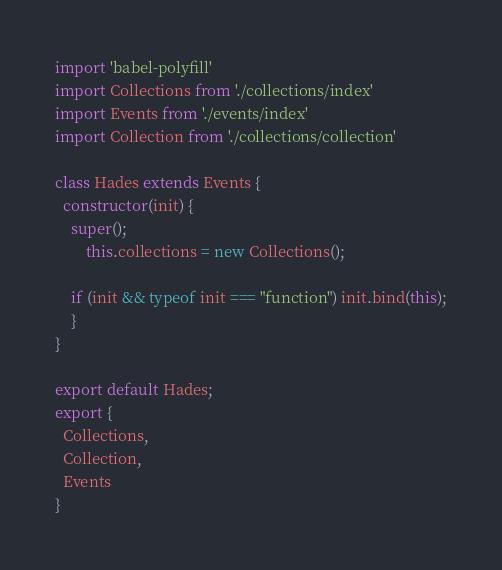Convert code to text. <code><loc_0><loc_0><loc_500><loc_500><_JavaScript_>import 'babel-polyfill'
import Collections from './collections/index'
import Events from './events/index'
import Collection from './collections/collection'

class Hades extends Events {
  constructor(init) {
    super();
		this.collections = new Collections();

    if (init && typeof init === "function") init.bind(this);
	}
}

export default Hades;
export {
  Collections,
  Collection,
  Events
}</code> 